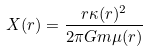<formula> <loc_0><loc_0><loc_500><loc_500>X ( r ) = \frac { r \kappa ( r ) ^ { 2 } } { 2 \pi G m \mu ( r ) }</formula> 